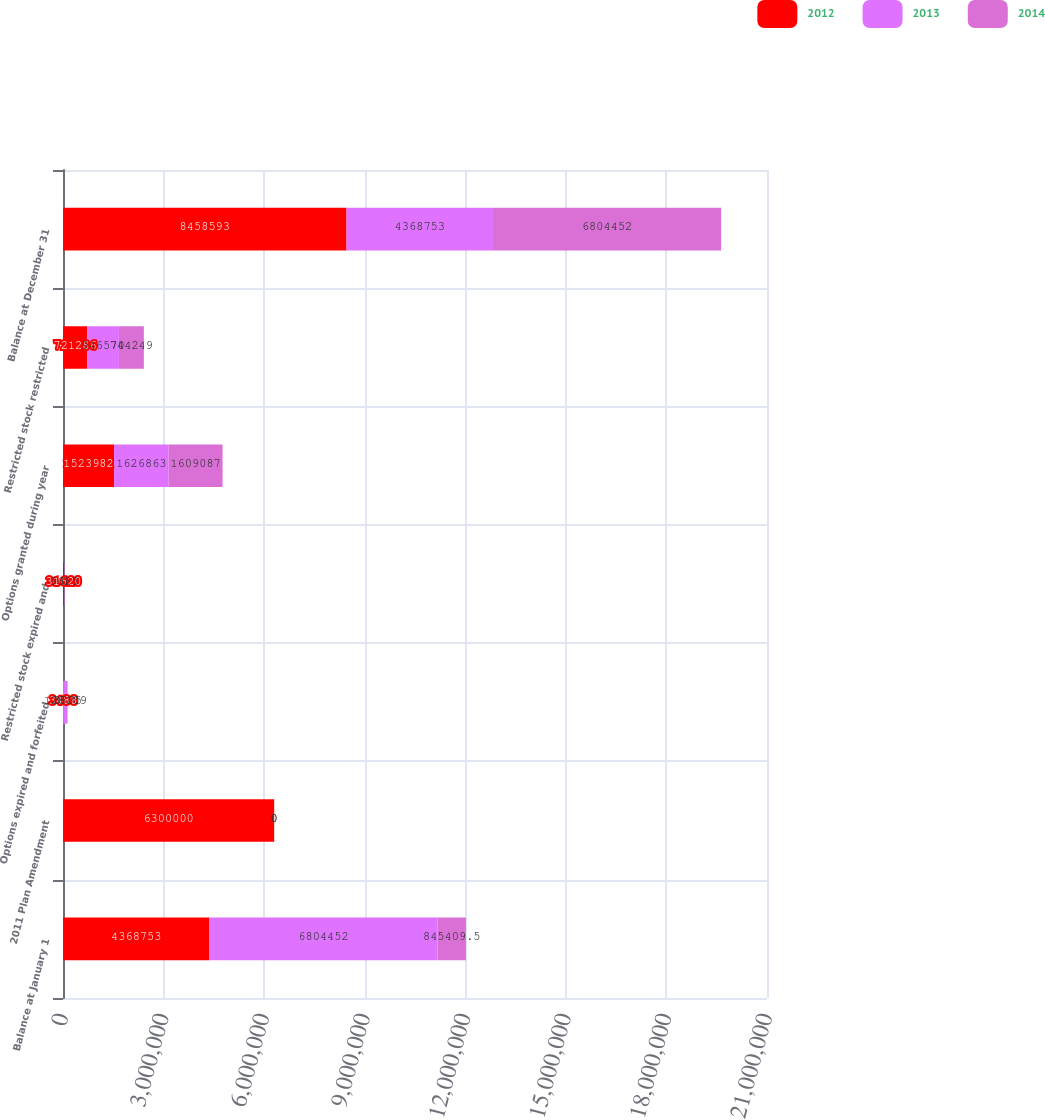Convert chart to OTSL. <chart><loc_0><loc_0><loc_500><loc_500><stacked_bar_chart><ecel><fcel>Balance at January 1<fcel>2011 Plan Amendment<fcel>Options expired and forfeited<fcel>Restricted stock expired and<fcel>Options granted during year<fcel>Restricted stock restricted<fcel>Balance at December 31<nl><fcel>2012<fcel>4.36875e+06<fcel>6.3e+06<fcel>3488<fcel>31620<fcel>1.52398e+06<fcel>721286<fcel>8.45859e+06<nl><fcel>2013<fcel>6.80445e+06<fcel>0<fcel>128109<fcel>9625<fcel>1.62686e+06<fcel>946570<fcel>4.36875e+06<nl><fcel>2014<fcel>845410<fcel>0<fcel>8775<fcel>0<fcel>1.60909e+06<fcel>744249<fcel>6.80445e+06<nl></chart> 